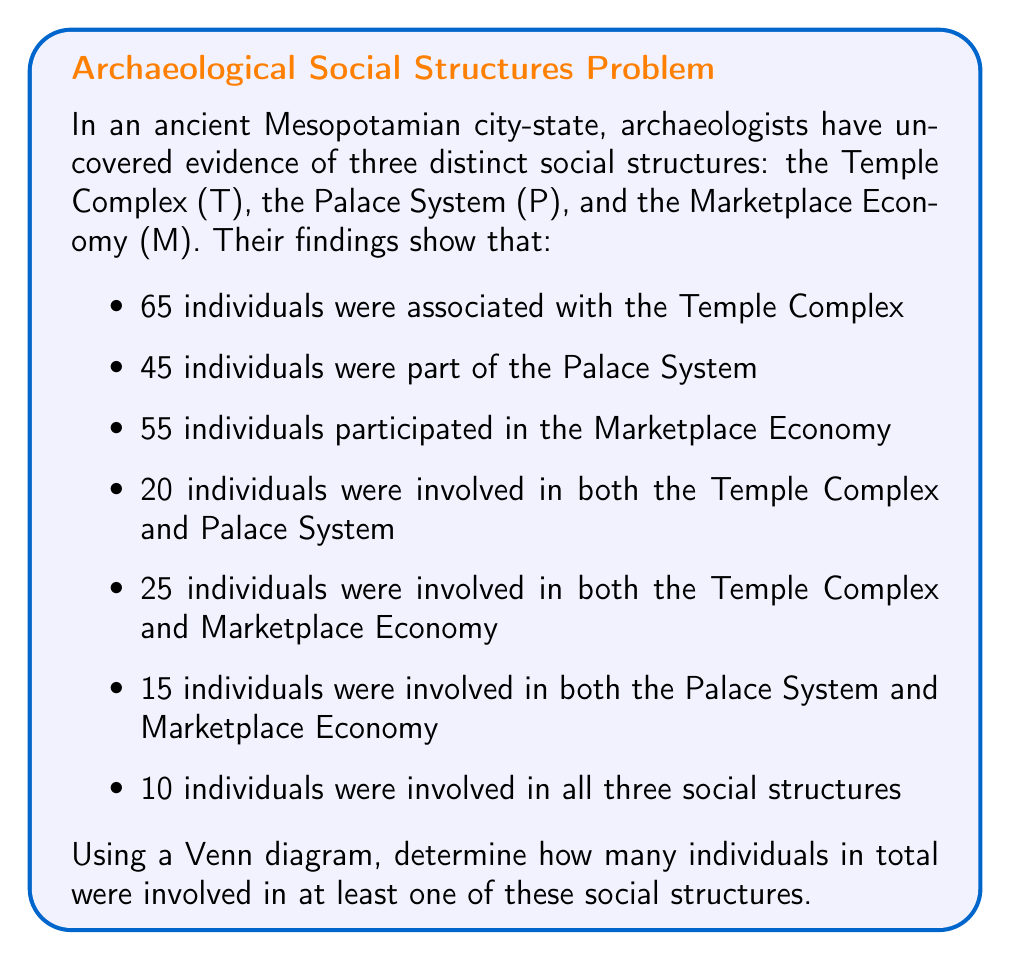What is the answer to this math problem? To solve this problem, we'll use a Venn diagram to visualize the relationships between the three social structures. Then we'll apply the principle of inclusion-exclusion to calculate the total number of individuals.

Let's break it down step by step:

1. Draw a Venn diagram with three overlapping circles representing T, P, and M.

2. Fill in the given information:
   - $|T \cap P \cap M| = 10$ (center)
   - $|T \cap P| - |T \cap P \cap M| = 20 - 10 = 10$
   - $|T \cap M| - |T \cap P \cap M| = 25 - 10 = 15$
   - $|P \cap M| - |T \cap P \cap M| = 15 - 10 = 5$

3. Calculate the number of individuals exclusive to each set:
   - T only: $65 - (10 + 10 + 15) = 30$
   - P only: $45 - (10 + 10 + 5) = 20$
   - M only: $55 - (15 + 5 + 10) = 25$

4. Apply the principle of inclusion-exclusion:

   $|T \cup P \cup M| = |T| + |P| + |M| - |T \cap P| - |T \cap M| - |P \cap M| + |T \cap P \cap M|$

   $= 65 + 45 + 55 - 20 - 25 - 15 + 10$

   $= 165 - 60 + 10$

   $= 115$

Therefore, the total number of individuals involved in at least one of these social structures is 115.
Answer: 115 individuals 